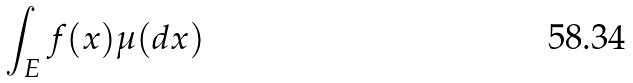<formula> <loc_0><loc_0><loc_500><loc_500>\int _ { E } f ( x ) \mu ( d x )</formula> 